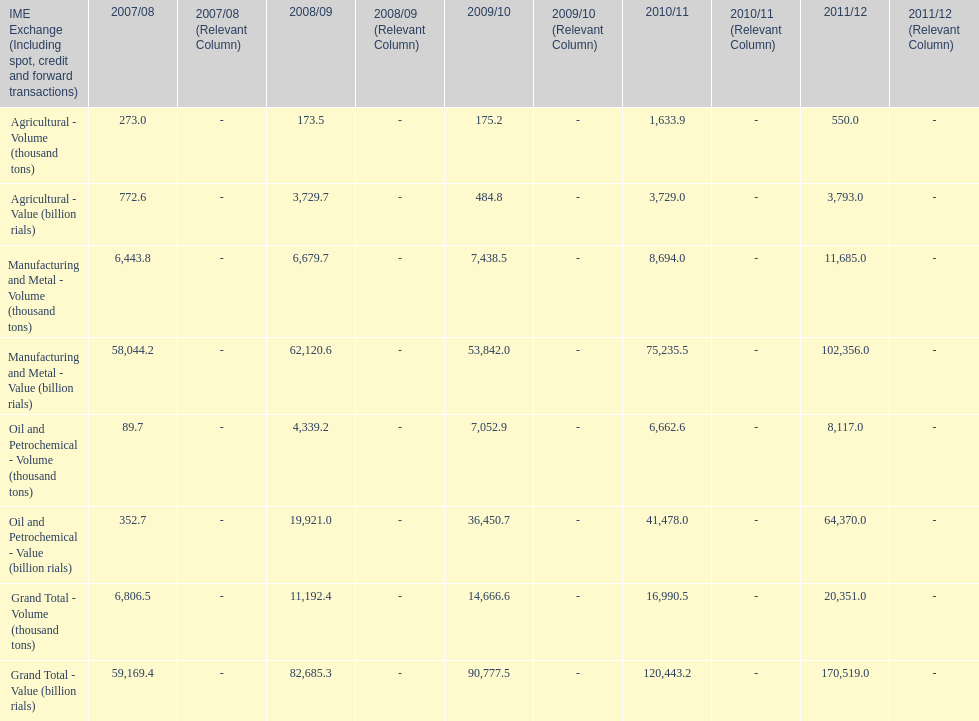In how many years was the value of agriculture, in billion rials, greater than 500 in iran? 4. 